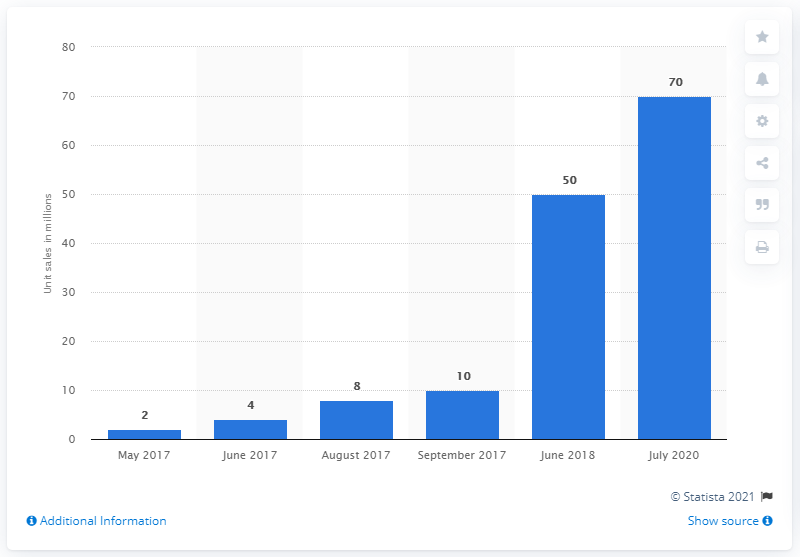Highlight a few significant elements in this photo. As of 2021, it is estimated that over 70 million copies of the popular game "PUBG" have been sold worldwide. 